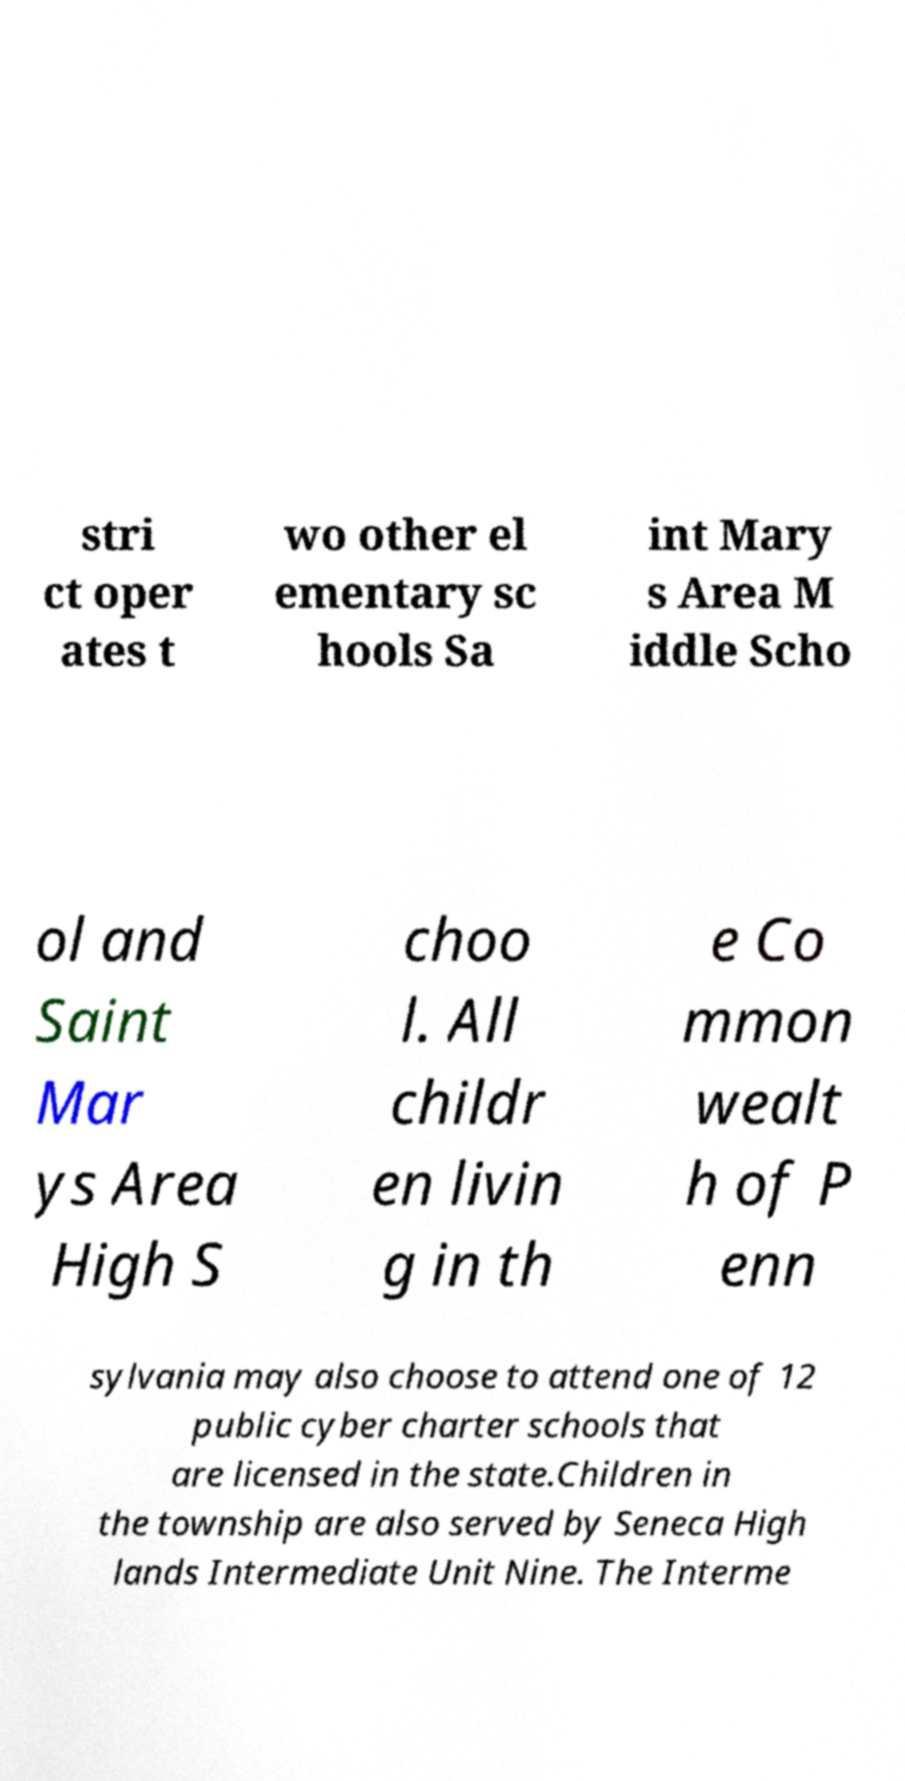Could you assist in decoding the text presented in this image and type it out clearly? stri ct oper ates t wo other el ementary sc hools Sa int Mary s Area M iddle Scho ol and Saint Mar ys Area High S choo l. All childr en livin g in th e Co mmon wealt h of P enn sylvania may also choose to attend one of 12 public cyber charter schools that are licensed in the state.Children in the township are also served by Seneca High lands Intermediate Unit Nine. The Interme 